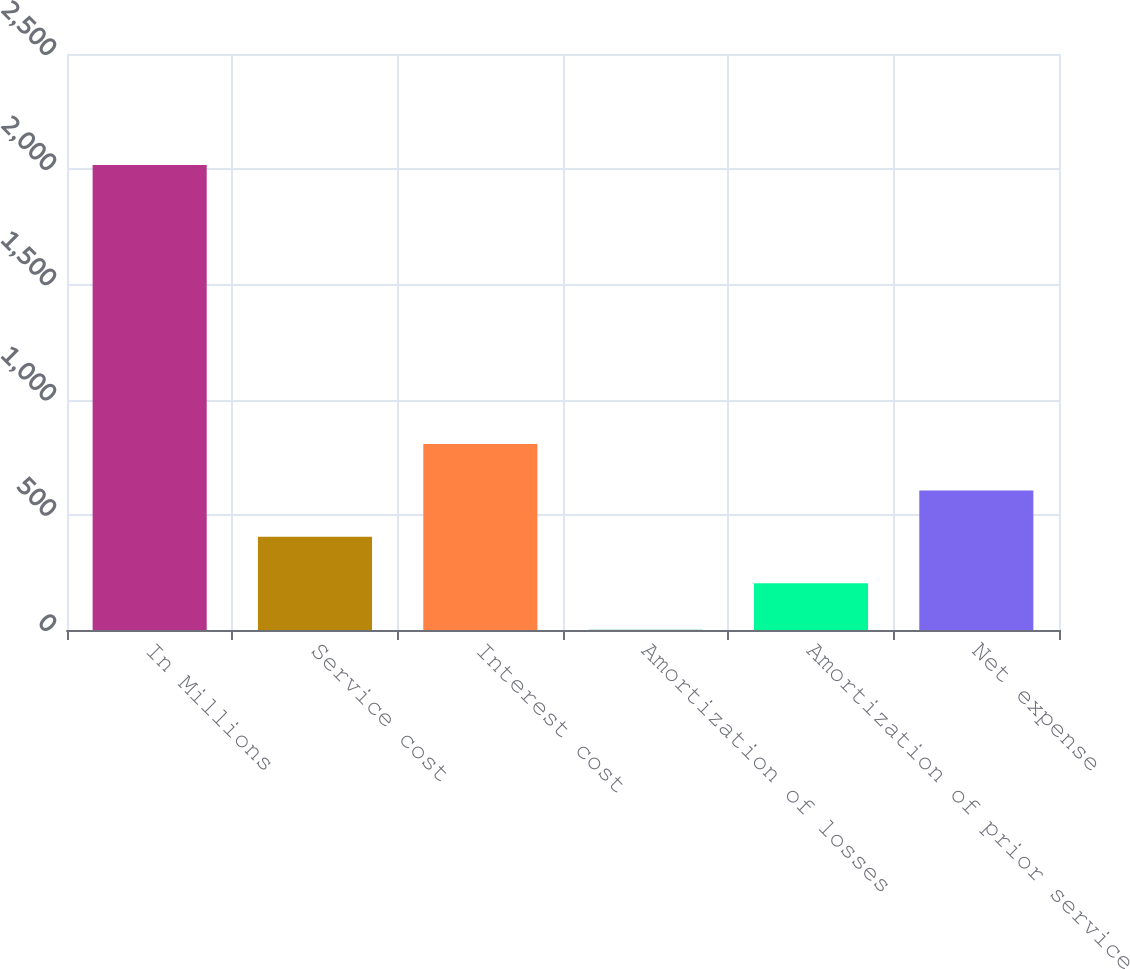<chart> <loc_0><loc_0><loc_500><loc_500><bar_chart><fcel>In Millions<fcel>Service cost<fcel>Interest cost<fcel>Amortization of losses<fcel>Amortization of prior service<fcel>Net expense<nl><fcel>2018<fcel>404.24<fcel>807.68<fcel>0.8<fcel>202.52<fcel>605.96<nl></chart> 